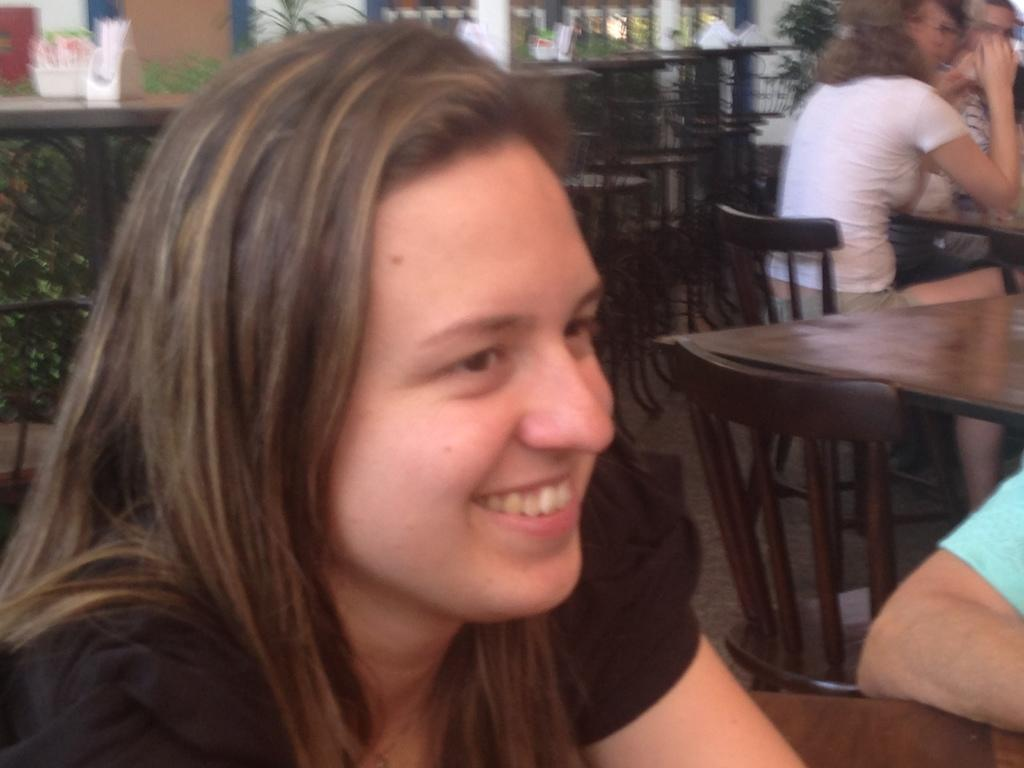What is the woman in the image wearing? The woman in the image is wearing a black dress. What expression does the woman have? The woman is smiling. What type of furniture can be seen in the image? There are chairs and tables in the image. What are the people in the image doing? People are sitting on the chairs. What can be seen in the distance in the image? There are plants in the distance. How many police officers are patrolling the area in the image? There are no police officers visible in the image. What type of pollution can be seen in the image? There is no pollution present in the image. 